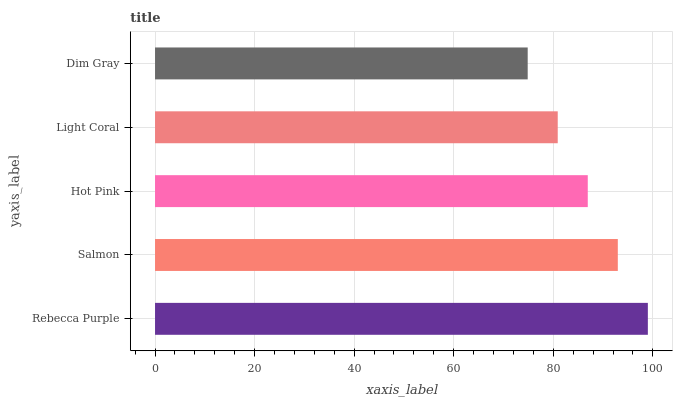Is Dim Gray the minimum?
Answer yes or no. Yes. Is Rebecca Purple the maximum?
Answer yes or no. Yes. Is Salmon the minimum?
Answer yes or no. No. Is Salmon the maximum?
Answer yes or no. No. Is Rebecca Purple greater than Salmon?
Answer yes or no. Yes. Is Salmon less than Rebecca Purple?
Answer yes or no. Yes. Is Salmon greater than Rebecca Purple?
Answer yes or no. No. Is Rebecca Purple less than Salmon?
Answer yes or no. No. Is Hot Pink the high median?
Answer yes or no. Yes. Is Hot Pink the low median?
Answer yes or no. Yes. Is Light Coral the high median?
Answer yes or no. No. Is Rebecca Purple the low median?
Answer yes or no. No. 